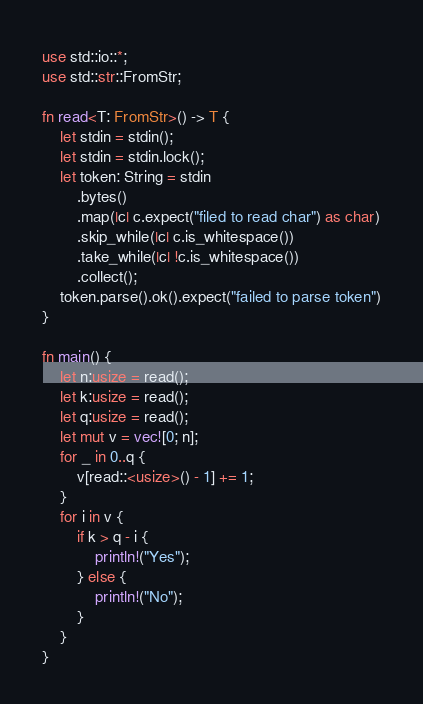<code> <loc_0><loc_0><loc_500><loc_500><_Rust_>use std::io::*;
use std::str::FromStr;

fn read<T: FromStr>() -> T {
    let stdin = stdin();
    let stdin = stdin.lock();
    let token: String = stdin
        .bytes()
        .map(|c| c.expect("filed to read char") as char)
        .skip_while(|c| c.is_whitespace())
        .take_while(|c| !c.is_whitespace())
        .collect();
    token.parse().ok().expect("failed to parse token")
}

fn main() {
    let n:usize = read();
    let k:usize = read();
    let q:usize = read();
    let mut v = vec![0; n];
    for _ in 0..q {
        v[read::<usize>() - 1] += 1;
    }
    for i in v {
        if k > q - i {
            println!("Yes");
        } else {
            println!("No");
        }
    }
}
</code> 